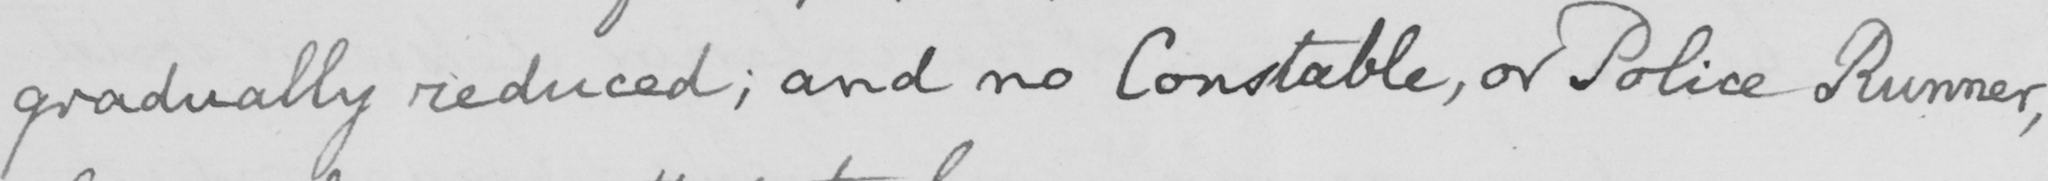What text is written in this handwritten line? gradually reduced ; and no Constable , or Police Runner , 